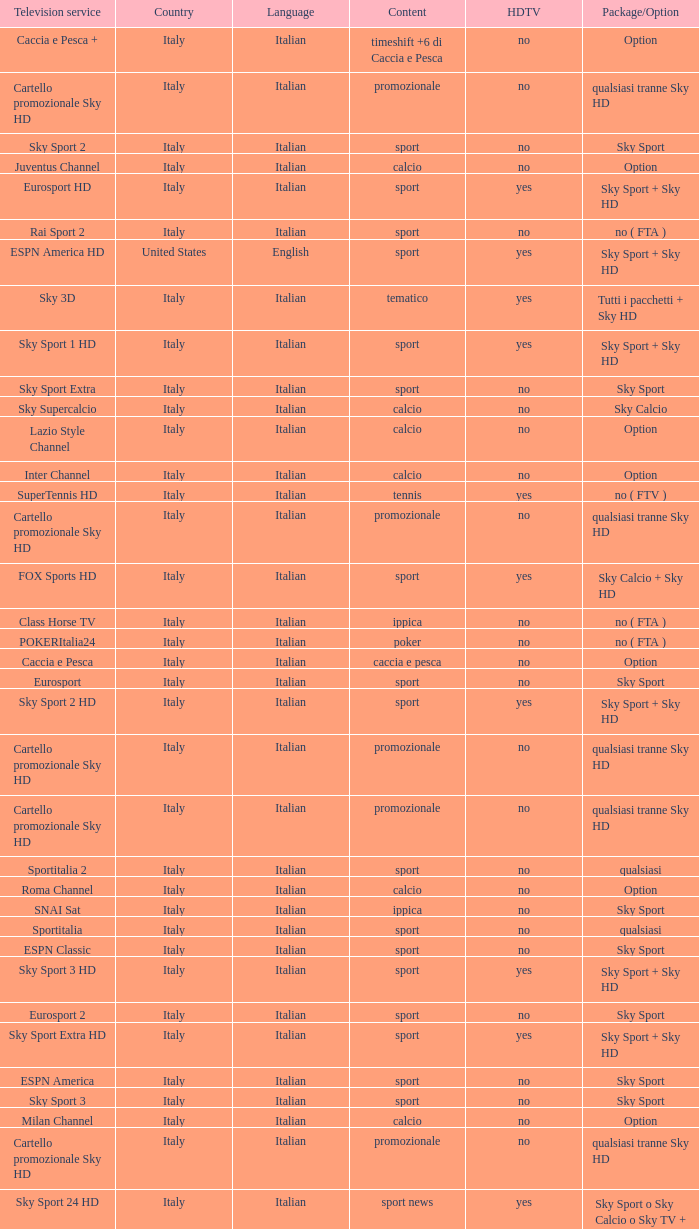What is Package/Option, when Content is Tennis? No ( ftv ). 